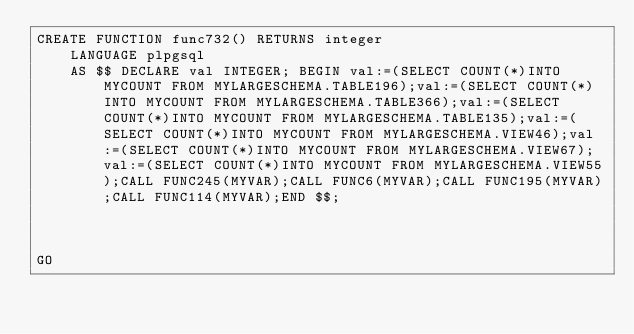<code> <loc_0><loc_0><loc_500><loc_500><_SQL_>CREATE FUNCTION func732() RETURNS integer
    LANGUAGE plpgsql
    AS $$ DECLARE val INTEGER; BEGIN val:=(SELECT COUNT(*)INTO MYCOUNT FROM MYLARGESCHEMA.TABLE196);val:=(SELECT COUNT(*)INTO MYCOUNT FROM MYLARGESCHEMA.TABLE366);val:=(SELECT COUNT(*)INTO MYCOUNT FROM MYLARGESCHEMA.TABLE135);val:=(SELECT COUNT(*)INTO MYCOUNT FROM MYLARGESCHEMA.VIEW46);val:=(SELECT COUNT(*)INTO MYCOUNT FROM MYLARGESCHEMA.VIEW67);val:=(SELECT COUNT(*)INTO MYCOUNT FROM MYLARGESCHEMA.VIEW55);CALL FUNC245(MYVAR);CALL FUNC6(MYVAR);CALL FUNC195(MYVAR);CALL FUNC114(MYVAR);END $$;



GO</code> 